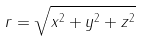<formula> <loc_0><loc_0><loc_500><loc_500>r = \sqrt { x ^ { 2 } + y ^ { 2 } + z ^ { 2 } }</formula> 